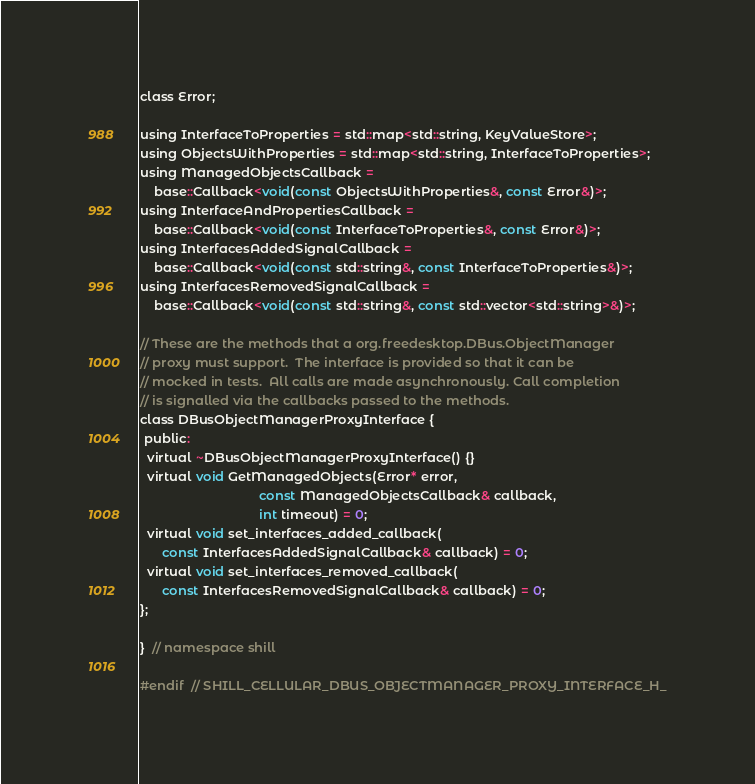<code> <loc_0><loc_0><loc_500><loc_500><_C_>class Error;

using InterfaceToProperties = std::map<std::string, KeyValueStore>;
using ObjectsWithProperties = std::map<std::string, InterfaceToProperties>;
using ManagedObjectsCallback =
    base::Callback<void(const ObjectsWithProperties&, const Error&)>;
using InterfaceAndPropertiesCallback =
    base::Callback<void(const InterfaceToProperties&, const Error&)>;
using InterfacesAddedSignalCallback =
    base::Callback<void(const std::string&, const InterfaceToProperties&)>;
using InterfacesRemovedSignalCallback =
    base::Callback<void(const std::string&, const std::vector<std::string>&)>;

// These are the methods that a org.freedesktop.DBus.ObjectManager
// proxy must support.  The interface is provided so that it can be
// mocked in tests.  All calls are made asynchronously. Call completion
// is signalled via the callbacks passed to the methods.
class DBusObjectManagerProxyInterface {
 public:
  virtual ~DBusObjectManagerProxyInterface() {}
  virtual void GetManagedObjects(Error* error,
                                 const ManagedObjectsCallback& callback,
                                 int timeout) = 0;
  virtual void set_interfaces_added_callback(
      const InterfacesAddedSignalCallback& callback) = 0;
  virtual void set_interfaces_removed_callback(
      const InterfacesRemovedSignalCallback& callback) = 0;
};

}  // namespace shill

#endif  // SHILL_CELLULAR_DBUS_OBJECTMANAGER_PROXY_INTERFACE_H_
</code> 